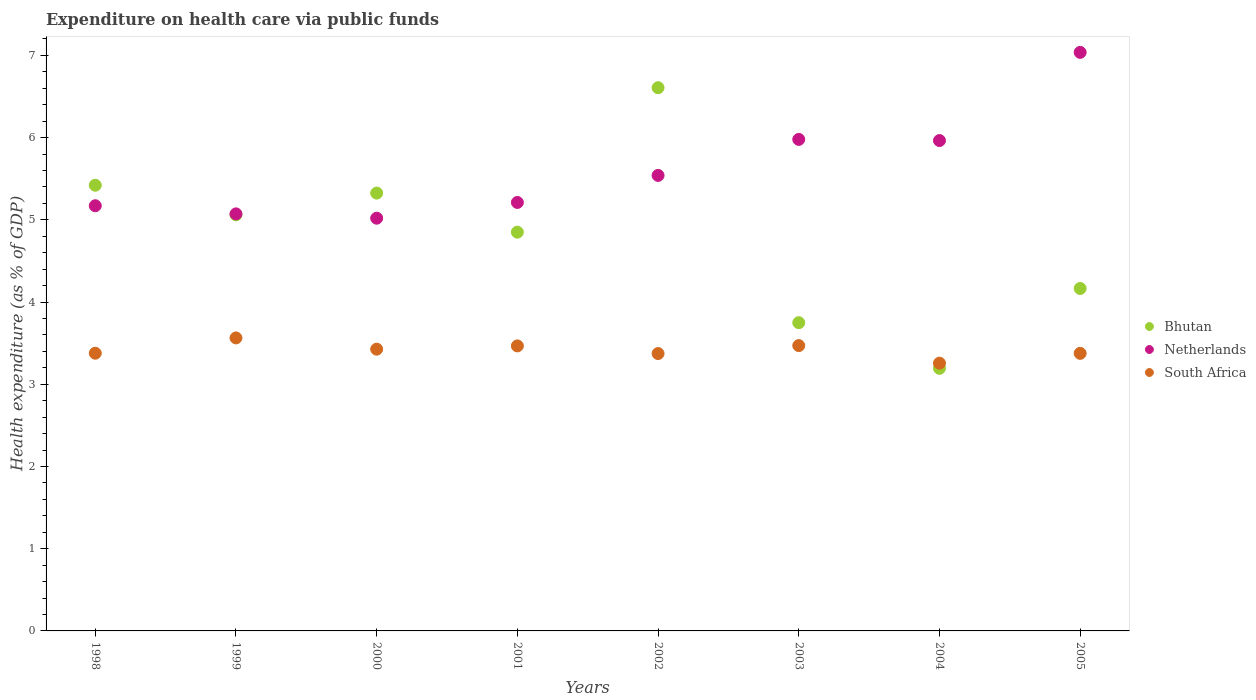What is the expenditure made on health care in South Africa in 2001?
Provide a succinct answer. 3.47. Across all years, what is the maximum expenditure made on health care in Netherlands?
Keep it short and to the point. 7.04. Across all years, what is the minimum expenditure made on health care in South Africa?
Offer a terse response. 3.26. In which year was the expenditure made on health care in Bhutan minimum?
Provide a succinct answer. 2004. What is the total expenditure made on health care in Netherlands in the graph?
Your response must be concise. 44.99. What is the difference between the expenditure made on health care in South Africa in 2000 and that in 2005?
Keep it short and to the point. 0.05. What is the difference between the expenditure made on health care in Netherlands in 2003 and the expenditure made on health care in South Africa in 2000?
Provide a succinct answer. 2.55. What is the average expenditure made on health care in Netherlands per year?
Give a very brief answer. 5.62. In the year 1998, what is the difference between the expenditure made on health care in Bhutan and expenditure made on health care in South Africa?
Your response must be concise. 2.04. In how many years, is the expenditure made on health care in Bhutan greater than 2 %?
Keep it short and to the point. 8. What is the ratio of the expenditure made on health care in Netherlands in 2001 to that in 2002?
Ensure brevity in your answer.  0.94. Is the difference between the expenditure made on health care in Bhutan in 2002 and 2003 greater than the difference between the expenditure made on health care in South Africa in 2002 and 2003?
Ensure brevity in your answer.  Yes. What is the difference between the highest and the second highest expenditure made on health care in South Africa?
Offer a very short reply. 0.09. What is the difference between the highest and the lowest expenditure made on health care in South Africa?
Offer a very short reply. 0.31. In how many years, is the expenditure made on health care in South Africa greater than the average expenditure made on health care in South Africa taken over all years?
Provide a short and direct response. 4. Is the sum of the expenditure made on health care in South Africa in 2002 and 2003 greater than the maximum expenditure made on health care in Netherlands across all years?
Keep it short and to the point. No. Is it the case that in every year, the sum of the expenditure made on health care in Bhutan and expenditure made on health care in South Africa  is greater than the expenditure made on health care in Netherlands?
Give a very brief answer. Yes. Does the expenditure made on health care in Bhutan monotonically increase over the years?
Provide a short and direct response. No. Is the expenditure made on health care in Netherlands strictly greater than the expenditure made on health care in Bhutan over the years?
Offer a very short reply. No. How many dotlines are there?
Make the answer very short. 3. What is the difference between two consecutive major ticks on the Y-axis?
Offer a terse response. 1. How many legend labels are there?
Offer a terse response. 3. What is the title of the graph?
Keep it short and to the point. Expenditure on health care via public funds. What is the label or title of the Y-axis?
Provide a succinct answer. Health expenditure (as % of GDP). What is the Health expenditure (as % of GDP) in Bhutan in 1998?
Your response must be concise. 5.42. What is the Health expenditure (as % of GDP) of Netherlands in 1998?
Your answer should be very brief. 5.17. What is the Health expenditure (as % of GDP) in South Africa in 1998?
Give a very brief answer. 3.38. What is the Health expenditure (as % of GDP) of Bhutan in 1999?
Make the answer very short. 5.06. What is the Health expenditure (as % of GDP) of Netherlands in 1999?
Your answer should be compact. 5.07. What is the Health expenditure (as % of GDP) of South Africa in 1999?
Your answer should be very brief. 3.56. What is the Health expenditure (as % of GDP) of Bhutan in 2000?
Offer a very short reply. 5.33. What is the Health expenditure (as % of GDP) of Netherlands in 2000?
Give a very brief answer. 5.02. What is the Health expenditure (as % of GDP) of South Africa in 2000?
Keep it short and to the point. 3.43. What is the Health expenditure (as % of GDP) in Bhutan in 2001?
Provide a succinct answer. 4.85. What is the Health expenditure (as % of GDP) in Netherlands in 2001?
Offer a very short reply. 5.21. What is the Health expenditure (as % of GDP) of South Africa in 2001?
Provide a short and direct response. 3.47. What is the Health expenditure (as % of GDP) in Bhutan in 2002?
Ensure brevity in your answer.  6.61. What is the Health expenditure (as % of GDP) of Netherlands in 2002?
Your response must be concise. 5.54. What is the Health expenditure (as % of GDP) in South Africa in 2002?
Offer a terse response. 3.37. What is the Health expenditure (as % of GDP) of Bhutan in 2003?
Offer a terse response. 3.75. What is the Health expenditure (as % of GDP) in Netherlands in 2003?
Offer a terse response. 5.98. What is the Health expenditure (as % of GDP) of South Africa in 2003?
Your answer should be compact. 3.47. What is the Health expenditure (as % of GDP) in Bhutan in 2004?
Offer a terse response. 3.19. What is the Health expenditure (as % of GDP) of Netherlands in 2004?
Give a very brief answer. 5.96. What is the Health expenditure (as % of GDP) of South Africa in 2004?
Offer a terse response. 3.26. What is the Health expenditure (as % of GDP) of Bhutan in 2005?
Make the answer very short. 4.17. What is the Health expenditure (as % of GDP) of Netherlands in 2005?
Your answer should be compact. 7.04. What is the Health expenditure (as % of GDP) in South Africa in 2005?
Your answer should be compact. 3.38. Across all years, what is the maximum Health expenditure (as % of GDP) in Bhutan?
Make the answer very short. 6.61. Across all years, what is the maximum Health expenditure (as % of GDP) in Netherlands?
Your answer should be compact. 7.04. Across all years, what is the maximum Health expenditure (as % of GDP) in South Africa?
Offer a very short reply. 3.56. Across all years, what is the minimum Health expenditure (as % of GDP) of Bhutan?
Provide a short and direct response. 3.19. Across all years, what is the minimum Health expenditure (as % of GDP) in Netherlands?
Provide a succinct answer. 5.02. Across all years, what is the minimum Health expenditure (as % of GDP) in South Africa?
Provide a succinct answer. 3.26. What is the total Health expenditure (as % of GDP) in Bhutan in the graph?
Ensure brevity in your answer.  38.37. What is the total Health expenditure (as % of GDP) of Netherlands in the graph?
Ensure brevity in your answer.  44.99. What is the total Health expenditure (as % of GDP) in South Africa in the graph?
Your answer should be very brief. 27.31. What is the difference between the Health expenditure (as % of GDP) of Bhutan in 1998 and that in 1999?
Ensure brevity in your answer.  0.36. What is the difference between the Health expenditure (as % of GDP) of Netherlands in 1998 and that in 1999?
Make the answer very short. 0.1. What is the difference between the Health expenditure (as % of GDP) of South Africa in 1998 and that in 1999?
Provide a succinct answer. -0.19. What is the difference between the Health expenditure (as % of GDP) in Bhutan in 1998 and that in 2000?
Provide a succinct answer. 0.1. What is the difference between the Health expenditure (as % of GDP) of Netherlands in 1998 and that in 2000?
Give a very brief answer. 0.15. What is the difference between the Health expenditure (as % of GDP) of South Africa in 1998 and that in 2000?
Your answer should be very brief. -0.05. What is the difference between the Health expenditure (as % of GDP) of Bhutan in 1998 and that in 2001?
Ensure brevity in your answer.  0.57. What is the difference between the Health expenditure (as % of GDP) of Netherlands in 1998 and that in 2001?
Provide a succinct answer. -0.04. What is the difference between the Health expenditure (as % of GDP) in South Africa in 1998 and that in 2001?
Make the answer very short. -0.09. What is the difference between the Health expenditure (as % of GDP) in Bhutan in 1998 and that in 2002?
Your answer should be very brief. -1.19. What is the difference between the Health expenditure (as % of GDP) in Netherlands in 1998 and that in 2002?
Provide a short and direct response. -0.37. What is the difference between the Health expenditure (as % of GDP) of South Africa in 1998 and that in 2002?
Provide a short and direct response. 0. What is the difference between the Health expenditure (as % of GDP) of Bhutan in 1998 and that in 2003?
Give a very brief answer. 1.67. What is the difference between the Health expenditure (as % of GDP) of Netherlands in 1998 and that in 2003?
Provide a short and direct response. -0.81. What is the difference between the Health expenditure (as % of GDP) in South Africa in 1998 and that in 2003?
Your answer should be compact. -0.09. What is the difference between the Health expenditure (as % of GDP) of Bhutan in 1998 and that in 2004?
Keep it short and to the point. 2.23. What is the difference between the Health expenditure (as % of GDP) of Netherlands in 1998 and that in 2004?
Keep it short and to the point. -0.79. What is the difference between the Health expenditure (as % of GDP) in South Africa in 1998 and that in 2004?
Your response must be concise. 0.12. What is the difference between the Health expenditure (as % of GDP) of Bhutan in 1998 and that in 2005?
Your response must be concise. 1.26. What is the difference between the Health expenditure (as % of GDP) of Netherlands in 1998 and that in 2005?
Make the answer very short. -1.87. What is the difference between the Health expenditure (as % of GDP) of South Africa in 1998 and that in 2005?
Offer a very short reply. 0. What is the difference between the Health expenditure (as % of GDP) in Bhutan in 1999 and that in 2000?
Make the answer very short. -0.26. What is the difference between the Health expenditure (as % of GDP) in Netherlands in 1999 and that in 2000?
Ensure brevity in your answer.  0.05. What is the difference between the Health expenditure (as % of GDP) of South Africa in 1999 and that in 2000?
Keep it short and to the point. 0.14. What is the difference between the Health expenditure (as % of GDP) in Bhutan in 1999 and that in 2001?
Offer a very short reply. 0.21. What is the difference between the Health expenditure (as % of GDP) of Netherlands in 1999 and that in 2001?
Provide a succinct answer. -0.14. What is the difference between the Health expenditure (as % of GDP) of South Africa in 1999 and that in 2001?
Keep it short and to the point. 0.1. What is the difference between the Health expenditure (as % of GDP) in Bhutan in 1999 and that in 2002?
Ensure brevity in your answer.  -1.55. What is the difference between the Health expenditure (as % of GDP) in Netherlands in 1999 and that in 2002?
Give a very brief answer. -0.47. What is the difference between the Health expenditure (as % of GDP) in South Africa in 1999 and that in 2002?
Offer a very short reply. 0.19. What is the difference between the Health expenditure (as % of GDP) of Bhutan in 1999 and that in 2003?
Your answer should be compact. 1.31. What is the difference between the Health expenditure (as % of GDP) of Netherlands in 1999 and that in 2003?
Ensure brevity in your answer.  -0.91. What is the difference between the Health expenditure (as % of GDP) of South Africa in 1999 and that in 2003?
Your response must be concise. 0.09. What is the difference between the Health expenditure (as % of GDP) of Bhutan in 1999 and that in 2004?
Your answer should be very brief. 1.87. What is the difference between the Health expenditure (as % of GDP) of Netherlands in 1999 and that in 2004?
Offer a terse response. -0.89. What is the difference between the Health expenditure (as % of GDP) in South Africa in 1999 and that in 2004?
Keep it short and to the point. 0.31. What is the difference between the Health expenditure (as % of GDP) in Bhutan in 1999 and that in 2005?
Your answer should be compact. 0.9. What is the difference between the Health expenditure (as % of GDP) in Netherlands in 1999 and that in 2005?
Provide a succinct answer. -1.96. What is the difference between the Health expenditure (as % of GDP) in South Africa in 1999 and that in 2005?
Offer a very short reply. 0.19. What is the difference between the Health expenditure (as % of GDP) of Bhutan in 2000 and that in 2001?
Provide a short and direct response. 0.48. What is the difference between the Health expenditure (as % of GDP) of Netherlands in 2000 and that in 2001?
Ensure brevity in your answer.  -0.19. What is the difference between the Health expenditure (as % of GDP) in South Africa in 2000 and that in 2001?
Provide a succinct answer. -0.04. What is the difference between the Health expenditure (as % of GDP) of Bhutan in 2000 and that in 2002?
Provide a succinct answer. -1.28. What is the difference between the Health expenditure (as % of GDP) in Netherlands in 2000 and that in 2002?
Your answer should be very brief. -0.52. What is the difference between the Health expenditure (as % of GDP) in South Africa in 2000 and that in 2002?
Keep it short and to the point. 0.05. What is the difference between the Health expenditure (as % of GDP) in Bhutan in 2000 and that in 2003?
Provide a short and direct response. 1.58. What is the difference between the Health expenditure (as % of GDP) of Netherlands in 2000 and that in 2003?
Your answer should be compact. -0.96. What is the difference between the Health expenditure (as % of GDP) in South Africa in 2000 and that in 2003?
Your response must be concise. -0.04. What is the difference between the Health expenditure (as % of GDP) in Bhutan in 2000 and that in 2004?
Make the answer very short. 2.13. What is the difference between the Health expenditure (as % of GDP) of Netherlands in 2000 and that in 2004?
Keep it short and to the point. -0.94. What is the difference between the Health expenditure (as % of GDP) in South Africa in 2000 and that in 2004?
Ensure brevity in your answer.  0.17. What is the difference between the Health expenditure (as % of GDP) in Bhutan in 2000 and that in 2005?
Make the answer very short. 1.16. What is the difference between the Health expenditure (as % of GDP) of Netherlands in 2000 and that in 2005?
Your answer should be very brief. -2.02. What is the difference between the Health expenditure (as % of GDP) in South Africa in 2000 and that in 2005?
Your answer should be very brief. 0.05. What is the difference between the Health expenditure (as % of GDP) of Bhutan in 2001 and that in 2002?
Keep it short and to the point. -1.76. What is the difference between the Health expenditure (as % of GDP) of Netherlands in 2001 and that in 2002?
Keep it short and to the point. -0.33. What is the difference between the Health expenditure (as % of GDP) in South Africa in 2001 and that in 2002?
Provide a short and direct response. 0.09. What is the difference between the Health expenditure (as % of GDP) of Bhutan in 2001 and that in 2003?
Ensure brevity in your answer.  1.1. What is the difference between the Health expenditure (as % of GDP) in Netherlands in 2001 and that in 2003?
Your response must be concise. -0.77. What is the difference between the Health expenditure (as % of GDP) of South Africa in 2001 and that in 2003?
Provide a short and direct response. -0. What is the difference between the Health expenditure (as % of GDP) of Bhutan in 2001 and that in 2004?
Your answer should be compact. 1.66. What is the difference between the Health expenditure (as % of GDP) in Netherlands in 2001 and that in 2004?
Give a very brief answer. -0.75. What is the difference between the Health expenditure (as % of GDP) in South Africa in 2001 and that in 2004?
Provide a short and direct response. 0.21. What is the difference between the Health expenditure (as % of GDP) in Bhutan in 2001 and that in 2005?
Provide a short and direct response. 0.68. What is the difference between the Health expenditure (as % of GDP) in Netherlands in 2001 and that in 2005?
Keep it short and to the point. -1.83. What is the difference between the Health expenditure (as % of GDP) of South Africa in 2001 and that in 2005?
Provide a succinct answer. 0.09. What is the difference between the Health expenditure (as % of GDP) in Bhutan in 2002 and that in 2003?
Offer a very short reply. 2.86. What is the difference between the Health expenditure (as % of GDP) in Netherlands in 2002 and that in 2003?
Offer a terse response. -0.44. What is the difference between the Health expenditure (as % of GDP) of South Africa in 2002 and that in 2003?
Your answer should be compact. -0.1. What is the difference between the Health expenditure (as % of GDP) of Bhutan in 2002 and that in 2004?
Give a very brief answer. 3.41. What is the difference between the Health expenditure (as % of GDP) in Netherlands in 2002 and that in 2004?
Offer a very short reply. -0.42. What is the difference between the Health expenditure (as % of GDP) in South Africa in 2002 and that in 2004?
Keep it short and to the point. 0.12. What is the difference between the Health expenditure (as % of GDP) in Bhutan in 2002 and that in 2005?
Provide a succinct answer. 2.44. What is the difference between the Health expenditure (as % of GDP) of Netherlands in 2002 and that in 2005?
Your answer should be compact. -1.5. What is the difference between the Health expenditure (as % of GDP) of South Africa in 2002 and that in 2005?
Offer a very short reply. -0. What is the difference between the Health expenditure (as % of GDP) of Bhutan in 2003 and that in 2004?
Your response must be concise. 0.56. What is the difference between the Health expenditure (as % of GDP) in Netherlands in 2003 and that in 2004?
Your answer should be compact. 0.01. What is the difference between the Health expenditure (as % of GDP) in South Africa in 2003 and that in 2004?
Provide a short and direct response. 0.21. What is the difference between the Health expenditure (as % of GDP) of Bhutan in 2003 and that in 2005?
Offer a very short reply. -0.42. What is the difference between the Health expenditure (as % of GDP) of Netherlands in 2003 and that in 2005?
Give a very brief answer. -1.06. What is the difference between the Health expenditure (as % of GDP) in South Africa in 2003 and that in 2005?
Offer a very short reply. 0.09. What is the difference between the Health expenditure (as % of GDP) in Bhutan in 2004 and that in 2005?
Give a very brief answer. -0.97. What is the difference between the Health expenditure (as % of GDP) of Netherlands in 2004 and that in 2005?
Offer a terse response. -1.07. What is the difference between the Health expenditure (as % of GDP) in South Africa in 2004 and that in 2005?
Provide a short and direct response. -0.12. What is the difference between the Health expenditure (as % of GDP) of Bhutan in 1998 and the Health expenditure (as % of GDP) of Netherlands in 1999?
Offer a very short reply. 0.35. What is the difference between the Health expenditure (as % of GDP) in Bhutan in 1998 and the Health expenditure (as % of GDP) in South Africa in 1999?
Make the answer very short. 1.86. What is the difference between the Health expenditure (as % of GDP) in Netherlands in 1998 and the Health expenditure (as % of GDP) in South Africa in 1999?
Your response must be concise. 1.61. What is the difference between the Health expenditure (as % of GDP) in Bhutan in 1998 and the Health expenditure (as % of GDP) in Netherlands in 2000?
Make the answer very short. 0.4. What is the difference between the Health expenditure (as % of GDP) of Bhutan in 1998 and the Health expenditure (as % of GDP) of South Africa in 2000?
Offer a terse response. 1.99. What is the difference between the Health expenditure (as % of GDP) of Netherlands in 1998 and the Health expenditure (as % of GDP) of South Africa in 2000?
Provide a short and direct response. 1.74. What is the difference between the Health expenditure (as % of GDP) of Bhutan in 1998 and the Health expenditure (as % of GDP) of Netherlands in 2001?
Make the answer very short. 0.21. What is the difference between the Health expenditure (as % of GDP) of Bhutan in 1998 and the Health expenditure (as % of GDP) of South Africa in 2001?
Keep it short and to the point. 1.95. What is the difference between the Health expenditure (as % of GDP) in Netherlands in 1998 and the Health expenditure (as % of GDP) in South Africa in 2001?
Your response must be concise. 1.7. What is the difference between the Health expenditure (as % of GDP) in Bhutan in 1998 and the Health expenditure (as % of GDP) in Netherlands in 2002?
Make the answer very short. -0.12. What is the difference between the Health expenditure (as % of GDP) in Bhutan in 1998 and the Health expenditure (as % of GDP) in South Africa in 2002?
Offer a terse response. 2.05. What is the difference between the Health expenditure (as % of GDP) in Netherlands in 1998 and the Health expenditure (as % of GDP) in South Africa in 2002?
Provide a short and direct response. 1.8. What is the difference between the Health expenditure (as % of GDP) in Bhutan in 1998 and the Health expenditure (as % of GDP) in Netherlands in 2003?
Offer a very short reply. -0.56. What is the difference between the Health expenditure (as % of GDP) of Bhutan in 1998 and the Health expenditure (as % of GDP) of South Africa in 2003?
Make the answer very short. 1.95. What is the difference between the Health expenditure (as % of GDP) of Netherlands in 1998 and the Health expenditure (as % of GDP) of South Africa in 2003?
Your answer should be compact. 1.7. What is the difference between the Health expenditure (as % of GDP) in Bhutan in 1998 and the Health expenditure (as % of GDP) in Netherlands in 2004?
Offer a very short reply. -0.54. What is the difference between the Health expenditure (as % of GDP) of Bhutan in 1998 and the Health expenditure (as % of GDP) of South Africa in 2004?
Your answer should be compact. 2.16. What is the difference between the Health expenditure (as % of GDP) of Netherlands in 1998 and the Health expenditure (as % of GDP) of South Africa in 2004?
Offer a terse response. 1.91. What is the difference between the Health expenditure (as % of GDP) of Bhutan in 1998 and the Health expenditure (as % of GDP) of Netherlands in 2005?
Keep it short and to the point. -1.62. What is the difference between the Health expenditure (as % of GDP) of Bhutan in 1998 and the Health expenditure (as % of GDP) of South Africa in 2005?
Give a very brief answer. 2.04. What is the difference between the Health expenditure (as % of GDP) of Netherlands in 1998 and the Health expenditure (as % of GDP) of South Africa in 2005?
Offer a very short reply. 1.8. What is the difference between the Health expenditure (as % of GDP) of Bhutan in 1999 and the Health expenditure (as % of GDP) of Netherlands in 2000?
Your answer should be compact. 0.04. What is the difference between the Health expenditure (as % of GDP) in Bhutan in 1999 and the Health expenditure (as % of GDP) in South Africa in 2000?
Your response must be concise. 1.63. What is the difference between the Health expenditure (as % of GDP) of Netherlands in 1999 and the Health expenditure (as % of GDP) of South Africa in 2000?
Ensure brevity in your answer.  1.65. What is the difference between the Health expenditure (as % of GDP) in Bhutan in 1999 and the Health expenditure (as % of GDP) in Netherlands in 2001?
Provide a short and direct response. -0.15. What is the difference between the Health expenditure (as % of GDP) in Bhutan in 1999 and the Health expenditure (as % of GDP) in South Africa in 2001?
Your answer should be compact. 1.59. What is the difference between the Health expenditure (as % of GDP) of Netherlands in 1999 and the Health expenditure (as % of GDP) of South Africa in 2001?
Keep it short and to the point. 1.61. What is the difference between the Health expenditure (as % of GDP) in Bhutan in 1999 and the Health expenditure (as % of GDP) in Netherlands in 2002?
Your answer should be compact. -0.48. What is the difference between the Health expenditure (as % of GDP) of Bhutan in 1999 and the Health expenditure (as % of GDP) of South Africa in 2002?
Give a very brief answer. 1.69. What is the difference between the Health expenditure (as % of GDP) of Netherlands in 1999 and the Health expenditure (as % of GDP) of South Africa in 2002?
Give a very brief answer. 1.7. What is the difference between the Health expenditure (as % of GDP) in Bhutan in 1999 and the Health expenditure (as % of GDP) in Netherlands in 2003?
Provide a succinct answer. -0.92. What is the difference between the Health expenditure (as % of GDP) in Bhutan in 1999 and the Health expenditure (as % of GDP) in South Africa in 2003?
Your answer should be very brief. 1.59. What is the difference between the Health expenditure (as % of GDP) in Netherlands in 1999 and the Health expenditure (as % of GDP) in South Africa in 2003?
Provide a short and direct response. 1.6. What is the difference between the Health expenditure (as % of GDP) in Bhutan in 1999 and the Health expenditure (as % of GDP) in Netherlands in 2004?
Offer a very short reply. -0.9. What is the difference between the Health expenditure (as % of GDP) in Bhutan in 1999 and the Health expenditure (as % of GDP) in South Africa in 2004?
Offer a very short reply. 1.8. What is the difference between the Health expenditure (as % of GDP) of Netherlands in 1999 and the Health expenditure (as % of GDP) of South Africa in 2004?
Keep it short and to the point. 1.82. What is the difference between the Health expenditure (as % of GDP) in Bhutan in 1999 and the Health expenditure (as % of GDP) in Netherlands in 2005?
Ensure brevity in your answer.  -1.98. What is the difference between the Health expenditure (as % of GDP) in Bhutan in 1999 and the Health expenditure (as % of GDP) in South Africa in 2005?
Ensure brevity in your answer.  1.68. What is the difference between the Health expenditure (as % of GDP) of Netherlands in 1999 and the Health expenditure (as % of GDP) of South Africa in 2005?
Your answer should be very brief. 1.7. What is the difference between the Health expenditure (as % of GDP) in Bhutan in 2000 and the Health expenditure (as % of GDP) in Netherlands in 2001?
Offer a terse response. 0.11. What is the difference between the Health expenditure (as % of GDP) of Bhutan in 2000 and the Health expenditure (as % of GDP) of South Africa in 2001?
Your answer should be very brief. 1.86. What is the difference between the Health expenditure (as % of GDP) of Netherlands in 2000 and the Health expenditure (as % of GDP) of South Africa in 2001?
Keep it short and to the point. 1.55. What is the difference between the Health expenditure (as % of GDP) of Bhutan in 2000 and the Health expenditure (as % of GDP) of Netherlands in 2002?
Give a very brief answer. -0.21. What is the difference between the Health expenditure (as % of GDP) in Bhutan in 2000 and the Health expenditure (as % of GDP) in South Africa in 2002?
Your response must be concise. 1.95. What is the difference between the Health expenditure (as % of GDP) of Netherlands in 2000 and the Health expenditure (as % of GDP) of South Africa in 2002?
Offer a very short reply. 1.65. What is the difference between the Health expenditure (as % of GDP) of Bhutan in 2000 and the Health expenditure (as % of GDP) of Netherlands in 2003?
Give a very brief answer. -0.65. What is the difference between the Health expenditure (as % of GDP) of Bhutan in 2000 and the Health expenditure (as % of GDP) of South Africa in 2003?
Your answer should be compact. 1.85. What is the difference between the Health expenditure (as % of GDP) of Netherlands in 2000 and the Health expenditure (as % of GDP) of South Africa in 2003?
Give a very brief answer. 1.55. What is the difference between the Health expenditure (as % of GDP) in Bhutan in 2000 and the Health expenditure (as % of GDP) in Netherlands in 2004?
Your response must be concise. -0.64. What is the difference between the Health expenditure (as % of GDP) of Bhutan in 2000 and the Health expenditure (as % of GDP) of South Africa in 2004?
Offer a very short reply. 2.07. What is the difference between the Health expenditure (as % of GDP) in Netherlands in 2000 and the Health expenditure (as % of GDP) in South Africa in 2004?
Keep it short and to the point. 1.76. What is the difference between the Health expenditure (as % of GDP) of Bhutan in 2000 and the Health expenditure (as % of GDP) of Netherlands in 2005?
Offer a very short reply. -1.71. What is the difference between the Health expenditure (as % of GDP) of Bhutan in 2000 and the Health expenditure (as % of GDP) of South Africa in 2005?
Offer a terse response. 1.95. What is the difference between the Health expenditure (as % of GDP) of Netherlands in 2000 and the Health expenditure (as % of GDP) of South Africa in 2005?
Make the answer very short. 1.64. What is the difference between the Health expenditure (as % of GDP) of Bhutan in 2001 and the Health expenditure (as % of GDP) of Netherlands in 2002?
Give a very brief answer. -0.69. What is the difference between the Health expenditure (as % of GDP) of Bhutan in 2001 and the Health expenditure (as % of GDP) of South Africa in 2002?
Make the answer very short. 1.48. What is the difference between the Health expenditure (as % of GDP) in Netherlands in 2001 and the Health expenditure (as % of GDP) in South Africa in 2002?
Your answer should be compact. 1.84. What is the difference between the Health expenditure (as % of GDP) in Bhutan in 2001 and the Health expenditure (as % of GDP) in Netherlands in 2003?
Your answer should be very brief. -1.13. What is the difference between the Health expenditure (as % of GDP) of Bhutan in 2001 and the Health expenditure (as % of GDP) of South Africa in 2003?
Make the answer very short. 1.38. What is the difference between the Health expenditure (as % of GDP) of Netherlands in 2001 and the Health expenditure (as % of GDP) of South Africa in 2003?
Give a very brief answer. 1.74. What is the difference between the Health expenditure (as % of GDP) in Bhutan in 2001 and the Health expenditure (as % of GDP) in Netherlands in 2004?
Keep it short and to the point. -1.11. What is the difference between the Health expenditure (as % of GDP) in Bhutan in 2001 and the Health expenditure (as % of GDP) in South Africa in 2004?
Offer a very short reply. 1.59. What is the difference between the Health expenditure (as % of GDP) in Netherlands in 2001 and the Health expenditure (as % of GDP) in South Africa in 2004?
Offer a terse response. 1.95. What is the difference between the Health expenditure (as % of GDP) in Bhutan in 2001 and the Health expenditure (as % of GDP) in Netherlands in 2005?
Provide a short and direct response. -2.19. What is the difference between the Health expenditure (as % of GDP) in Bhutan in 2001 and the Health expenditure (as % of GDP) in South Africa in 2005?
Keep it short and to the point. 1.47. What is the difference between the Health expenditure (as % of GDP) in Netherlands in 2001 and the Health expenditure (as % of GDP) in South Africa in 2005?
Your response must be concise. 1.84. What is the difference between the Health expenditure (as % of GDP) of Bhutan in 2002 and the Health expenditure (as % of GDP) of Netherlands in 2003?
Your answer should be compact. 0.63. What is the difference between the Health expenditure (as % of GDP) in Bhutan in 2002 and the Health expenditure (as % of GDP) in South Africa in 2003?
Offer a very short reply. 3.14. What is the difference between the Health expenditure (as % of GDP) in Netherlands in 2002 and the Health expenditure (as % of GDP) in South Africa in 2003?
Offer a very short reply. 2.07. What is the difference between the Health expenditure (as % of GDP) of Bhutan in 2002 and the Health expenditure (as % of GDP) of Netherlands in 2004?
Your response must be concise. 0.64. What is the difference between the Health expenditure (as % of GDP) of Bhutan in 2002 and the Health expenditure (as % of GDP) of South Africa in 2004?
Give a very brief answer. 3.35. What is the difference between the Health expenditure (as % of GDP) of Netherlands in 2002 and the Health expenditure (as % of GDP) of South Africa in 2004?
Make the answer very short. 2.28. What is the difference between the Health expenditure (as % of GDP) in Bhutan in 2002 and the Health expenditure (as % of GDP) in Netherlands in 2005?
Make the answer very short. -0.43. What is the difference between the Health expenditure (as % of GDP) in Bhutan in 2002 and the Health expenditure (as % of GDP) in South Africa in 2005?
Make the answer very short. 3.23. What is the difference between the Health expenditure (as % of GDP) in Netherlands in 2002 and the Health expenditure (as % of GDP) in South Africa in 2005?
Provide a succinct answer. 2.16. What is the difference between the Health expenditure (as % of GDP) of Bhutan in 2003 and the Health expenditure (as % of GDP) of Netherlands in 2004?
Keep it short and to the point. -2.21. What is the difference between the Health expenditure (as % of GDP) of Bhutan in 2003 and the Health expenditure (as % of GDP) of South Africa in 2004?
Give a very brief answer. 0.49. What is the difference between the Health expenditure (as % of GDP) in Netherlands in 2003 and the Health expenditure (as % of GDP) in South Africa in 2004?
Offer a terse response. 2.72. What is the difference between the Health expenditure (as % of GDP) of Bhutan in 2003 and the Health expenditure (as % of GDP) of Netherlands in 2005?
Provide a short and direct response. -3.29. What is the difference between the Health expenditure (as % of GDP) in Bhutan in 2003 and the Health expenditure (as % of GDP) in South Africa in 2005?
Provide a succinct answer. 0.37. What is the difference between the Health expenditure (as % of GDP) of Netherlands in 2003 and the Health expenditure (as % of GDP) of South Africa in 2005?
Provide a short and direct response. 2.6. What is the difference between the Health expenditure (as % of GDP) in Bhutan in 2004 and the Health expenditure (as % of GDP) in Netherlands in 2005?
Your answer should be very brief. -3.84. What is the difference between the Health expenditure (as % of GDP) of Bhutan in 2004 and the Health expenditure (as % of GDP) of South Africa in 2005?
Your answer should be compact. -0.18. What is the difference between the Health expenditure (as % of GDP) in Netherlands in 2004 and the Health expenditure (as % of GDP) in South Africa in 2005?
Offer a terse response. 2.59. What is the average Health expenditure (as % of GDP) of Bhutan per year?
Offer a terse response. 4.8. What is the average Health expenditure (as % of GDP) in Netherlands per year?
Your answer should be compact. 5.62. What is the average Health expenditure (as % of GDP) in South Africa per year?
Your response must be concise. 3.41. In the year 1998, what is the difference between the Health expenditure (as % of GDP) in Bhutan and Health expenditure (as % of GDP) in Netherlands?
Offer a very short reply. 0.25. In the year 1998, what is the difference between the Health expenditure (as % of GDP) of Bhutan and Health expenditure (as % of GDP) of South Africa?
Offer a terse response. 2.04. In the year 1998, what is the difference between the Health expenditure (as % of GDP) of Netherlands and Health expenditure (as % of GDP) of South Africa?
Offer a terse response. 1.79. In the year 1999, what is the difference between the Health expenditure (as % of GDP) in Bhutan and Health expenditure (as % of GDP) in Netherlands?
Give a very brief answer. -0.01. In the year 1999, what is the difference between the Health expenditure (as % of GDP) in Bhutan and Health expenditure (as % of GDP) in South Africa?
Make the answer very short. 1.5. In the year 1999, what is the difference between the Health expenditure (as % of GDP) in Netherlands and Health expenditure (as % of GDP) in South Africa?
Keep it short and to the point. 1.51. In the year 2000, what is the difference between the Health expenditure (as % of GDP) of Bhutan and Health expenditure (as % of GDP) of Netherlands?
Give a very brief answer. 0.31. In the year 2000, what is the difference between the Health expenditure (as % of GDP) of Bhutan and Health expenditure (as % of GDP) of South Africa?
Your response must be concise. 1.9. In the year 2000, what is the difference between the Health expenditure (as % of GDP) in Netherlands and Health expenditure (as % of GDP) in South Africa?
Give a very brief answer. 1.59. In the year 2001, what is the difference between the Health expenditure (as % of GDP) in Bhutan and Health expenditure (as % of GDP) in Netherlands?
Offer a very short reply. -0.36. In the year 2001, what is the difference between the Health expenditure (as % of GDP) of Bhutan and Health expenditure (as % of GDP) of South Africa?
Ensure brevity in your answer.  1.38. In the year 2001, what is the difference between the Health expenditure (as % of GDP) of Netherlands and Health expenditure (as % of GDP) of South Africa?
Make the answer very short. 1.74. In the year 2002, what is the difference between the Health expenditure (as % of GDP) in Bhutan and Health expenditure (as % of GDP) in Netherlands?
Keep it short and to the point. 1.07. In the year 2002, what is the difference between the Health expenditure (as % of GDP) of Bhutan and Health expenditure (as % of GDP) of South Africa?
Offer a very short reply. 3.23. In the year 2002, what is the difference between the Health expenditure (as % of GDP) of Netherlands and Health expenditure (as % of GDP) of South Africa?
Give a very brief answer. 2.17. In the year 2003, what is the difference between the Health expenditure (as % of GDP) in Bhutan and Health expenditure (as % of GDP) in Netherlands?
Your response must be concise. -2.23. In the year 2003, what is the difference between the Health expenditure (as % of GDP) in Bhutan and Health expenditure (as % of GDP) in South Africa?
Provide a succinct answer. 0.28. In the year 2003, what is the difference between the Health expenditure (as % of GDP) of Netherlands and Health expenditure (as % of GDP) of South Africa?
Give a very brief answer. 2.51. In the year 2004, what is the difference between the Health expenditure (as % of GDP) in Bhutan and Health expenditure (as % of GDP) in Netherlands?
Your answer should be compact. -2.77. In the year 2004, what is the difference between the Health expenditure (as % of GDP) in Bhutan and Health expenditure (as % of GDP) in South Africa?
Give a very brief answer. -0.06. In the year 2004, what is the difference between the Health expenditure (as % of GDP) in Netherlands and Health expenditure (as % of GDP) in South Africa?
Make the answer very short. 2.71. In the year 2005, what is the difference between the Health expenditure (as % of GDP) in Bhutan and Health expenditure (as % of GDP) in Netherlands?
Give a very brief answer. -2.87. In the year 2005, what is the difference between the Health expenditure (as % of GDP) of Bhutan and Health expenditure (as % of GDP) of South Africa?
Provide a succinct answer. 0.79. In the year 2005, what is the difference between the Health expenditure (as % of GDP) of Netherlands and Health expenditure (as % of GDP) of South Africa?
Provide a succinct answer. 3.66. What is the ratio of the Health expenditure (as % of GDP) in Bhutan in 1998 to that in 1999?
Your answer should be compact. 1.07. What is the ratio of the Health expenditure (as % of GDP) in Netherlands in 1998 to that in 1999?
Make the answer very short. 1.02. What is the ratio of the Health expenditure (as % of GDP) of South Africa in 1998 to that in 1999?
Give a very brief answer. 0.95. What is the ratio of the Health expenditure (as % of GDP) of Netherlands in 1998 to that in 2000?
Make the answer very short. 1.03. What is the ratio of the Health expenditure (as % of GDP) of South Africa in 1998 to that in 2000?
Give a very brief answer. 0.99. What is the ratio of the Health expenditure (as % of GDP) of Bhutan in 1998 to that in 2001?
Offer a very short reply. 1.12. What is the ratio of the Health expenditure (as % of GDP) of South Africa in 1998 to that in 2001?
Provide a succinct answer. 0.97. What is the ratio of the Health expenditure (as % of GDP) of Bhutan in 1998 to that in 2002?
Keep it short and to the point. 0.82. What is the ratio of the Health expenditure (as % of GDP) of Netherlands in 1998 to that in 2002?
Your answer should be compact. 0.93. What is the ratio of the Health expenditure (as % of GDP) in South Africa in 1998 to that in 2002?
Your answer should be very brief. 1. What is the ratio of the Health expenditure (as % of GDP) in Bhutan in 1998 to that in 2003?
Provide a succinct answer. 1.45. What is the ratio of the Health expenditure (as % of GDP) of Netherlands in 1998 to that in 2003?
Give a very brief answer. 0.86. What is the ratio of the Health expenditure (as % of GDP) of South Africa in 1998 to that in 2003?
Ensure brevity in your answer.  0.97. What is the ratio of the Health expenditure (as % of GDP) of Bhutan in 1998 to that in 2004?
Give a very brief answer. 1.7. What is the ratio of the Health expenditure (as % of GDP) in Netherlands in 1998 to that in 2004?
Provide a short and direct response. 0.87. What is the ratio of the Health expenditure (as % of GDP) in South Africa in 1998 to that in 2004?
Offer a terse response. 1.04. What is the ratio of the Health expenditure (as % of GDP) in Bhutan in 1998 to that in 2005?
Make the answer very short. 1.3. What is the ratio of the Health expenditure (as % of GDP) in Netherlands in 1998 to that in 2005?
Provide a short and direct response. 0.73. What is the ratio of the Health expenditure (as % of GDP) of Bhutan in 1999 to that in 2000?
Offer a terse response. 0.95. What is the ratio of the Health expenditure (as % of GDP) of Netherlands in 1999 to that in 2000?
Offer a very short reply. 1.01. What is the ratio of the Health expenditure (as % of GDP) of South Africa in 1999 to that in 2000?
Make the answer very short. 1.04. What is the ratio of the Health expenditure (as % of GDP) in Bhutan in 1999 to that in 2001?
Provide a succinct answer. 1.04. What is the ratio of the Health expenditure (as % of GDP) of Netherlands in 1999 to that in 2001?
Ensure brevity in your answer.  0.97. What is the ratio of the Health expenditure (as % of GDP) of South Africa in 1999 to that in 2001?
Provide a short and direct response. 1.03. What is the ratio of the Health expenditure (as % of GDP) in Bhutan in 1999 to that in 2002?
Your response must be concise. 0.77. What is the ratio of the Health expenditure (as % of GDP) in Netherlands in 1999 to that in 2002?
Make the answer very short. 0.92. What is the ratio of the Health expenditure (as % of GDP) of South Africa in 1999 to that in 2002?
Your answer should be compact. 1.06. What is the ratio of the Health expenditure (as % of GDP) of Bhutan in 1999 to that in 2003?
Offer a terse response. 1.35. What is the ratio of the Health expenditure (as % of GDP) in Netherlands in 1999 to that in 2003?
Give a very brief answer. 0.85. What is the ratio of the Health expenditure (as % of GDP) of South Africa in 1999 to that in 2003?
Offer a very short reply. 1.03. What is the ratio of the Health expenditure (as % of GDP) of Bhutan in 1999 to that in 2004?
Offer a terse response. 1.58. What is the ratio of the Health expenditure (as % of GDP) in Netherlands in 1999 to that in 2004?
Your response must be concise. 0.85. What is the ratio of the Health expenditure (as % of GDP) of South Africa in 1999 to that in 2004?
Ensure brevity in your answer.  1.09. What is the ratio of the Health expenditure (as % of GDP) in Bhutan in 1999 to that in 2005?
Your response must be concise. 1.22. What is the ratio of the Health expenditure (as % of GDP) of Netherlands in 1999 to that in 2005?
Provide a short and direct response. 0.72. What is the ratio of the Health expenditure (as % of GDP) of South Africa in 1999 to that in 2005?
Keep it short and to the point. 1.06. What is the ratio of the Health expenditure (as % of GDP) in Bhutan in 2000 to that in 2001?
Your answer should be very brief. 1.1. What is the ratio of the Health expenditure (as % of GDP) of Netherlands in 2000 to that in 2001?
Offer a very short reply. 0.96. What is the ratio of the Health expenditure (as % of GDP) in South Africa in 2000 to that in 2001?
Your response must be concise. 0.99. What is the ratio of the Health expenditure (as % of GDP) in Bhutan in 2000 to that in 2002?
Your response must be concise. 0.81. What is the ratio of the Health expenditure (as % of GDP) in Netherlands in 2000 to that in 2002?
Offer a very short reply. 0.91. What is the ratio of the Health expenditure (as % of GDP) of South Africa in 2000 to that in 2002?
Keep it short and to the point. 1.02. What is the ratio of the Health expenditure (as % of GDP) in Bhutan in 2000 to that in 2003?
Your answer should be compact. 1.42. What is the ratio of the Health expenditure (as % of GDP) of Netherlands in 2000 to that in 2003?
Provide a succinct answer. 0.84. What is the ratio of the Health expenditure (as % of GDP) in South Africa in 2000 to that in 2003?
Ensure brevity in your answer.  0.99. What is the ratio of the Health expenditure (as % of GDP) of Bhutan in 2000 to that in 2004?
Your answer should be compact. 1.67. What is the ratio of the Health expenditure (as % of GDP) of Netherlands in 2000 to that in 2004?
Your answer should be very brief. 0.84. What is the ratio of the Health expenditure (as % of GDP) in South Africa in 2000 to that in 2004?
Provide a succinct answer. 1.05. What is the ratio of the Health expenditure (as % of GDP) in Bhutan in 2000 to that in 2005?
Offer a terse response. 1.28. What is the ratio of the Health expenditure (as % of GDP) of Netherlands in 2000 to that in 2005?
Give a very brief answer. 0.71. What is the ratio of the Health expenditure (as % of GDP) in Bhutan in 2001 to that in 2002?
Your answer should be compact. 0.73. What is the ratio of the Health expenditure (as % of GDP) in Netherlands in 2001 to that in 2002?
Provide a succinct answer. 0.94. What is the ratio of the Health expenditure (as % of GDP) of South Africa in 2001 to that in 2002?
Provide a succinct answer. 1.03. What is the ratio of the Health expenditure (as % of GDP) in Bhutan in 2001 to that in 2003?
Offer a very short reply. 1.29. What is the ratio of the Health expenditure (as % of GDP) in Netherlands in 2001 to that in 2003?
Your response must be concise. 0.87. What is the ratio of the Health expenditure (as % of GDP) of South Africa in 2001 to that in 2003?
Your answer should be compact. 1. What is the ratio of the Health expenditure (as % of GDP) in Bhutan in 2001 to that in 2004?
Make the answer very short. 1.52. What is the ratio of the Health expenditure (as % of GDP) in Netherlands in 2001 to that in 2004?
Ensure brevity in your answer.  0.87. What is the ratio of the Health expenditure (as % of GDP) in South Africa in 2001 to that in 2004?
Offer a very short reply. 1.06. What is the ratio of the Health expenditure (as % of GDP) in Bhutan in 2001 to that in 2005?
Make the answer very short. 1.16. What is the ratio of the Health expenditure (as % of GDP) in Netherlands in 2001 to that in 2005?
Your answer should be very brief. 0.74. What is the ratio of the Health expenditure (as % of GDP) in South Africa in 2001 to that in 2005?
Provide a succinct answer. 1.03. What is the ratio of the Health expenditure (as % of GDP) in Bhutan in 2002 to that in 2003?
Keep it short and to the point. 1.76. What is the ratio of the Health expenditure (as % of GDP) in Netherlands in 2002 to that in 2003?
Keep it short and to the point. 0.93. What is the ratio of the Health expenditure (as % of GDP) of South Africa in 2002 to that in 2003?
Make the answer very short. 0.97. What is the ratio of the Health expenditure (as % of GDP) of Bhutan in 2002 to that in 2004?
Offer a terse response. 2.07. What is the ratio of the Health expenditure (as % of GDP) in Netherlands in 2002 to that in 2004?
Give a very brief answer. 0.93. What is the ratio of the Health expenditure (as % of GDP) in South Africa in 2002 to that in 2004?
Your answer should be compact. 1.04. What is the ratio of the Health expenditure (as % of GDP) in Bhutan in 2002 to that in 2005?
Provide a succinct answer. 1.59. What is the ratio of the Health expenditure (as % of GDP) in Netherlands in 2002 to that in 2005?
Make the answer very short. 0.79. What is the ratio of the Health expenditure (as % of GDP) of South Africa in 2002 to that in 2005?
Offer a terse response. 1. What is the ratio of the Health expenditure (as % of GDP) of Bhutan in 2003 to that in 2004?
Provide a short and direct response. 1.17. What is the ratio of the Health expenditure (as % of GDP) of South Africa in 2003 to that in 2004?
Your answer should be compact. 1.07. What is the ratio of the Health expenditure (as % of GDP) in Bhutan in 2003 to that in 2005?
Your answer should be very brief. 0.9. What is the ratio of the Health expenditure (as % of GDP) in Netherlands in 2003 to that in 2005?
Give a very brief answer. 0.85. What is the ratio of the Health expenditure (as % of GDP) of South Africa in 2003 to that in 2005?
Keep it short and to the point. 1.03. What is the ratio of the Health expenditure (as % of GDP) of Bhutan in 2004 to that in 2005?
Offer a very short reply. 0.77. What is the ratio of the Health expenditure (as % of GDP) in Netherlands in 2004 to that in 2005?
Offer a very short reply. 0.85. What is the ratio of the Health expenditure (as % of GDP) in South Africa in 2004 to that in 2005?
Keep it short and to the point. 0.96. What is the difference between the highest and the second highest Health expenditure (as % of GDP) of Bhutan?
Your answer should be very brief. 1.19. What is the difference between the highest and the second highest Health expenditure (as % of GDP) in Netherlands?
Offer a terse response. 1.06. What is the difference between the highest and the second highest Health expenditure (as % of GDP) of South Africa?
Make the answer very short. 0.09. What is the difference between the highest and the lowest Health expenditure (as % of GDP) of Bhutan?
Provide a succinct answer. 3.41. What is the difference between the highest and the lowest Health expenditure (as % of GDP) in Netherlands?
Ensure brevity in your answer.  2.02. What is the difference between the highest and the lowest Health expenditure (as % of GDP) of South Africa?
Ensure brevity in your answer.  0.31. 